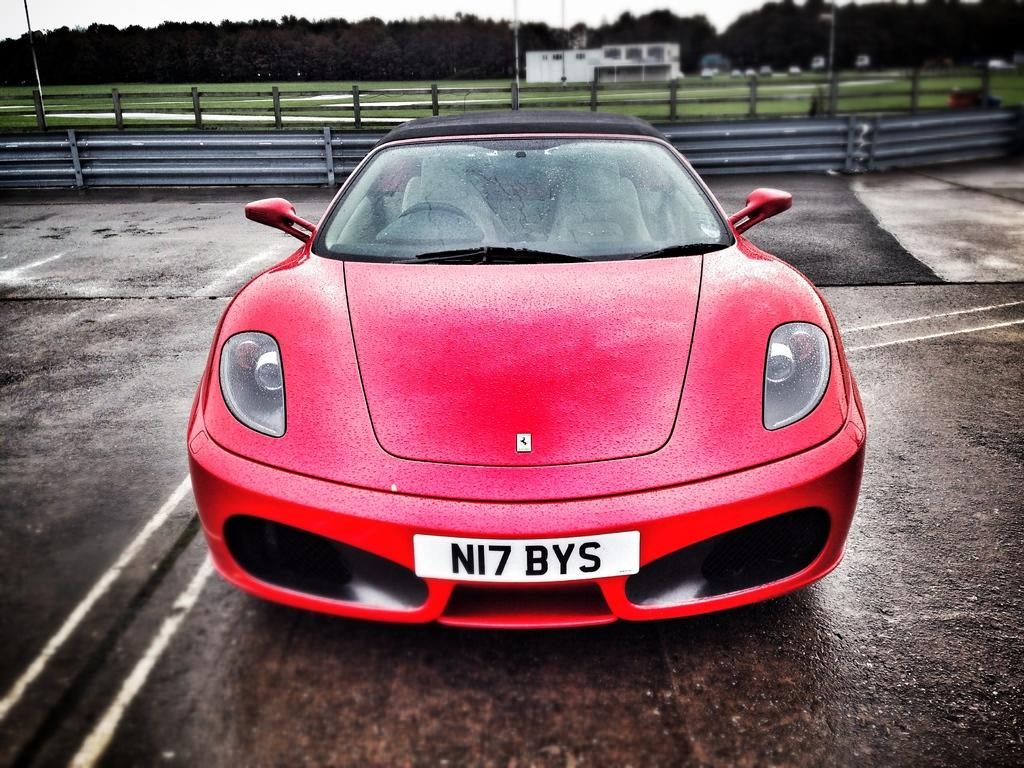What is the main subject of the image? There is a car on the road in the image. What can be seen in the background of the image? In the background of the image, there is a fence, poles, a house, vehicles, trees, and the sky. How many types of structures are visible in the background? There are at least three types of structures visible in the background: a fence, poles, and a house. What type of natural elements are present in the background? Trees and the sky are present in the background. What is the taste of the square in the image? There is no square present in the image, so it is not possible to determine its taste. 